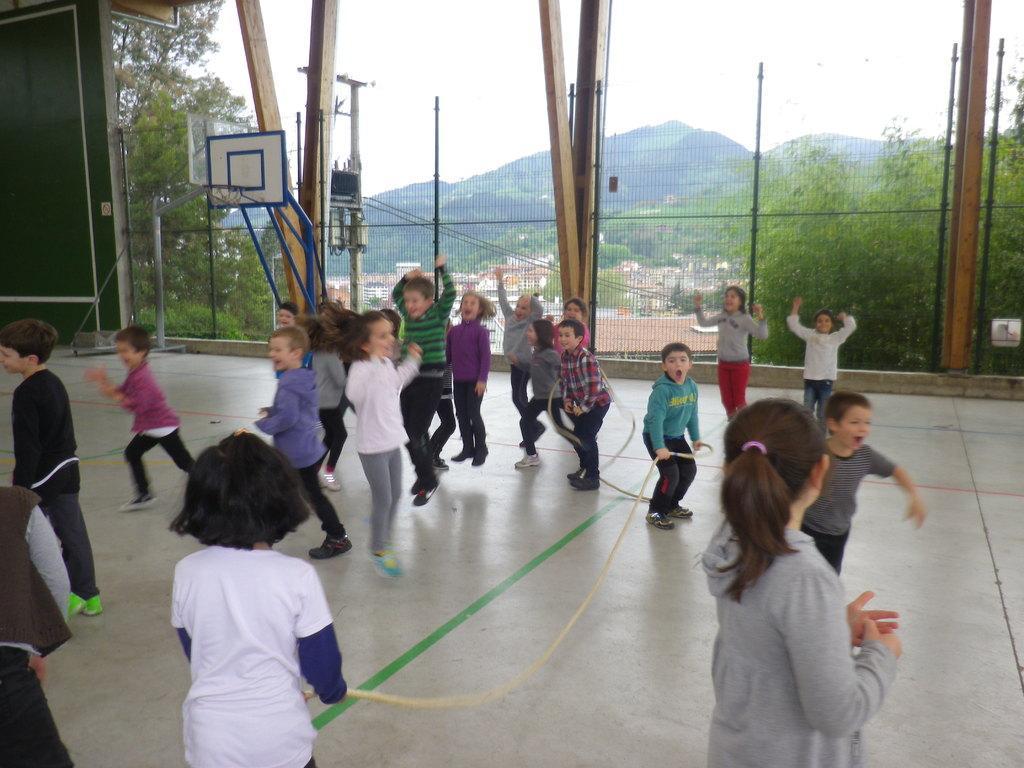Could you give a brief overview of what you see in this image? On the left side a child is standing, this child wore white color t-shirt and here few children are jumping, playing the games. This is an iron net, outside this there are trees. 